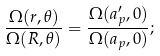<formula> <loc_0><loc_0><loc_500><loc_500>\frac { \Omega ( r , \theta ) } { \Omega ( R , \theta ) } = \frac { \Omega ( a _ { p } ^ { \prime } , 0 ) } { \Omega ( a _ { p } , 0 ) } ;</formula> 